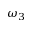<formula> <loc_0><loc_0><loc_500><loc_500>\omega _ { 3 }</formula> 